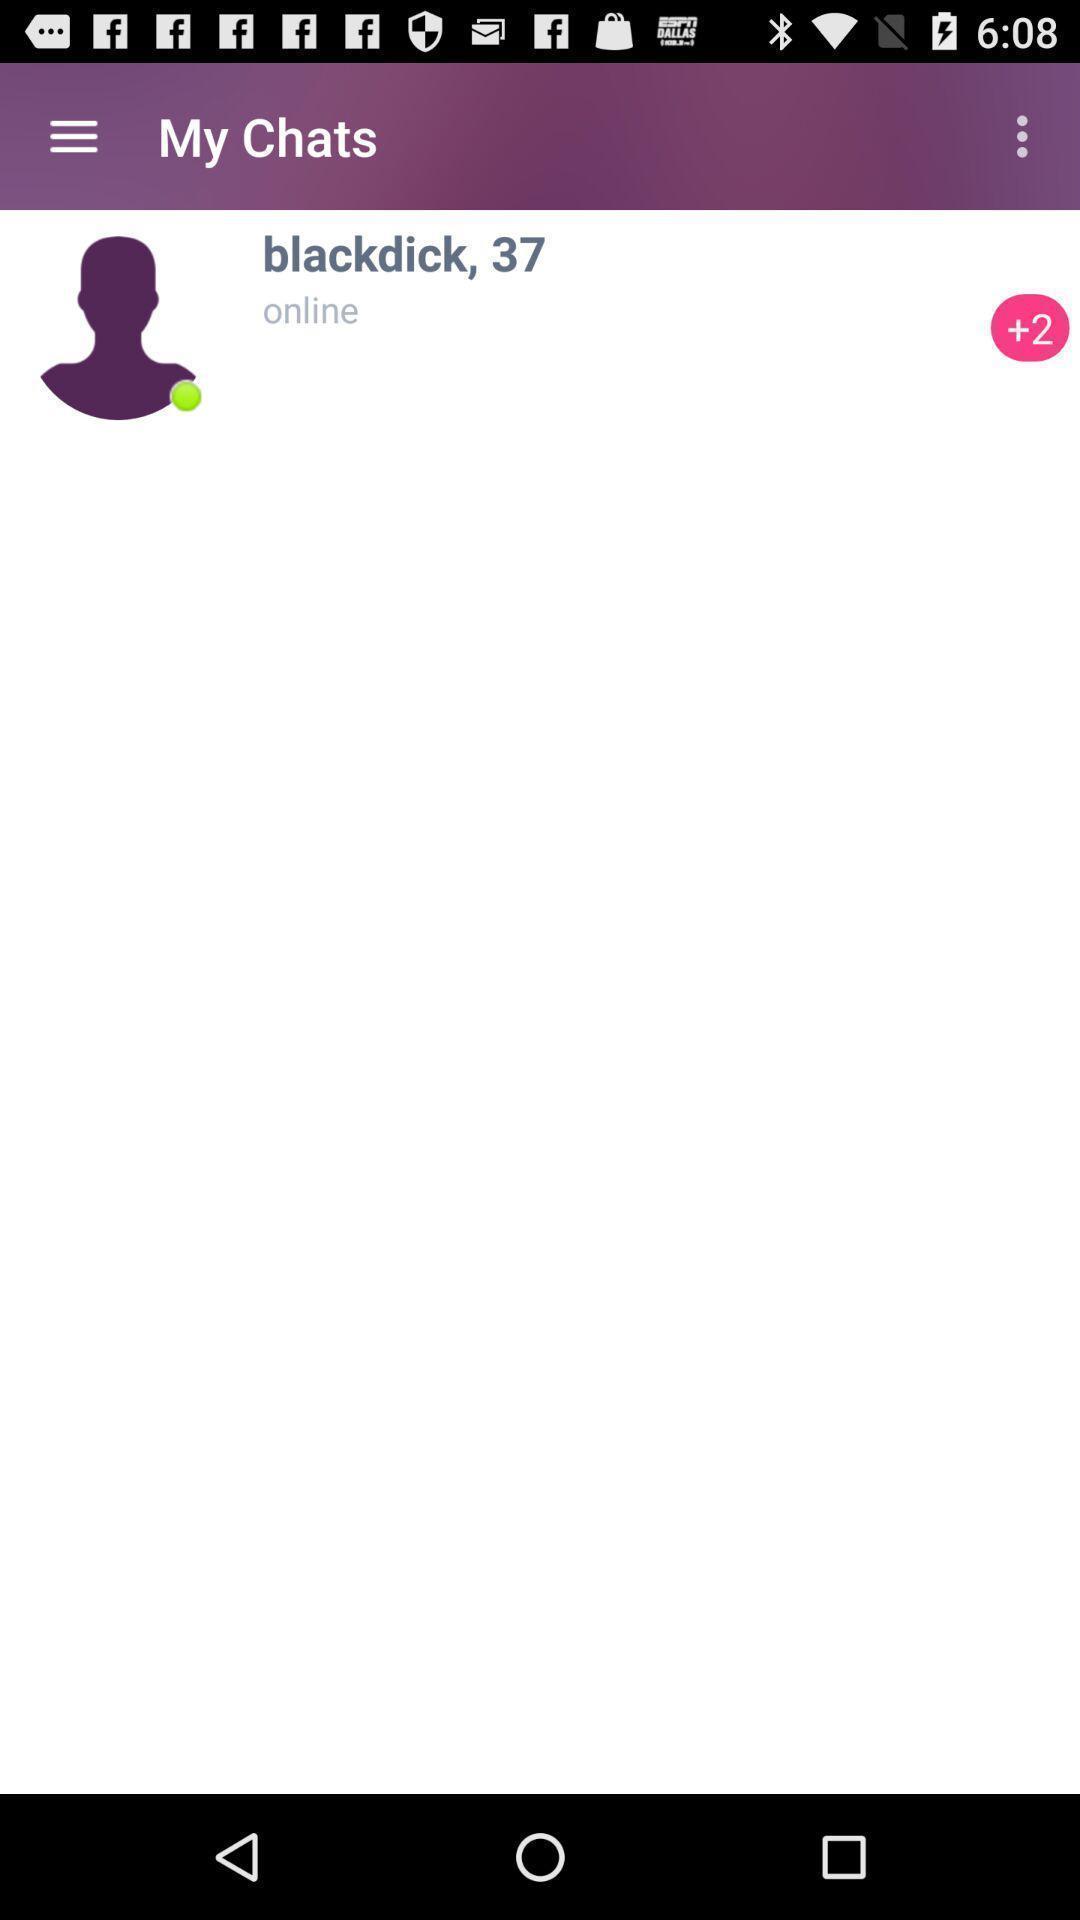Describe this image in words. Screen page of a chat in a social app. 